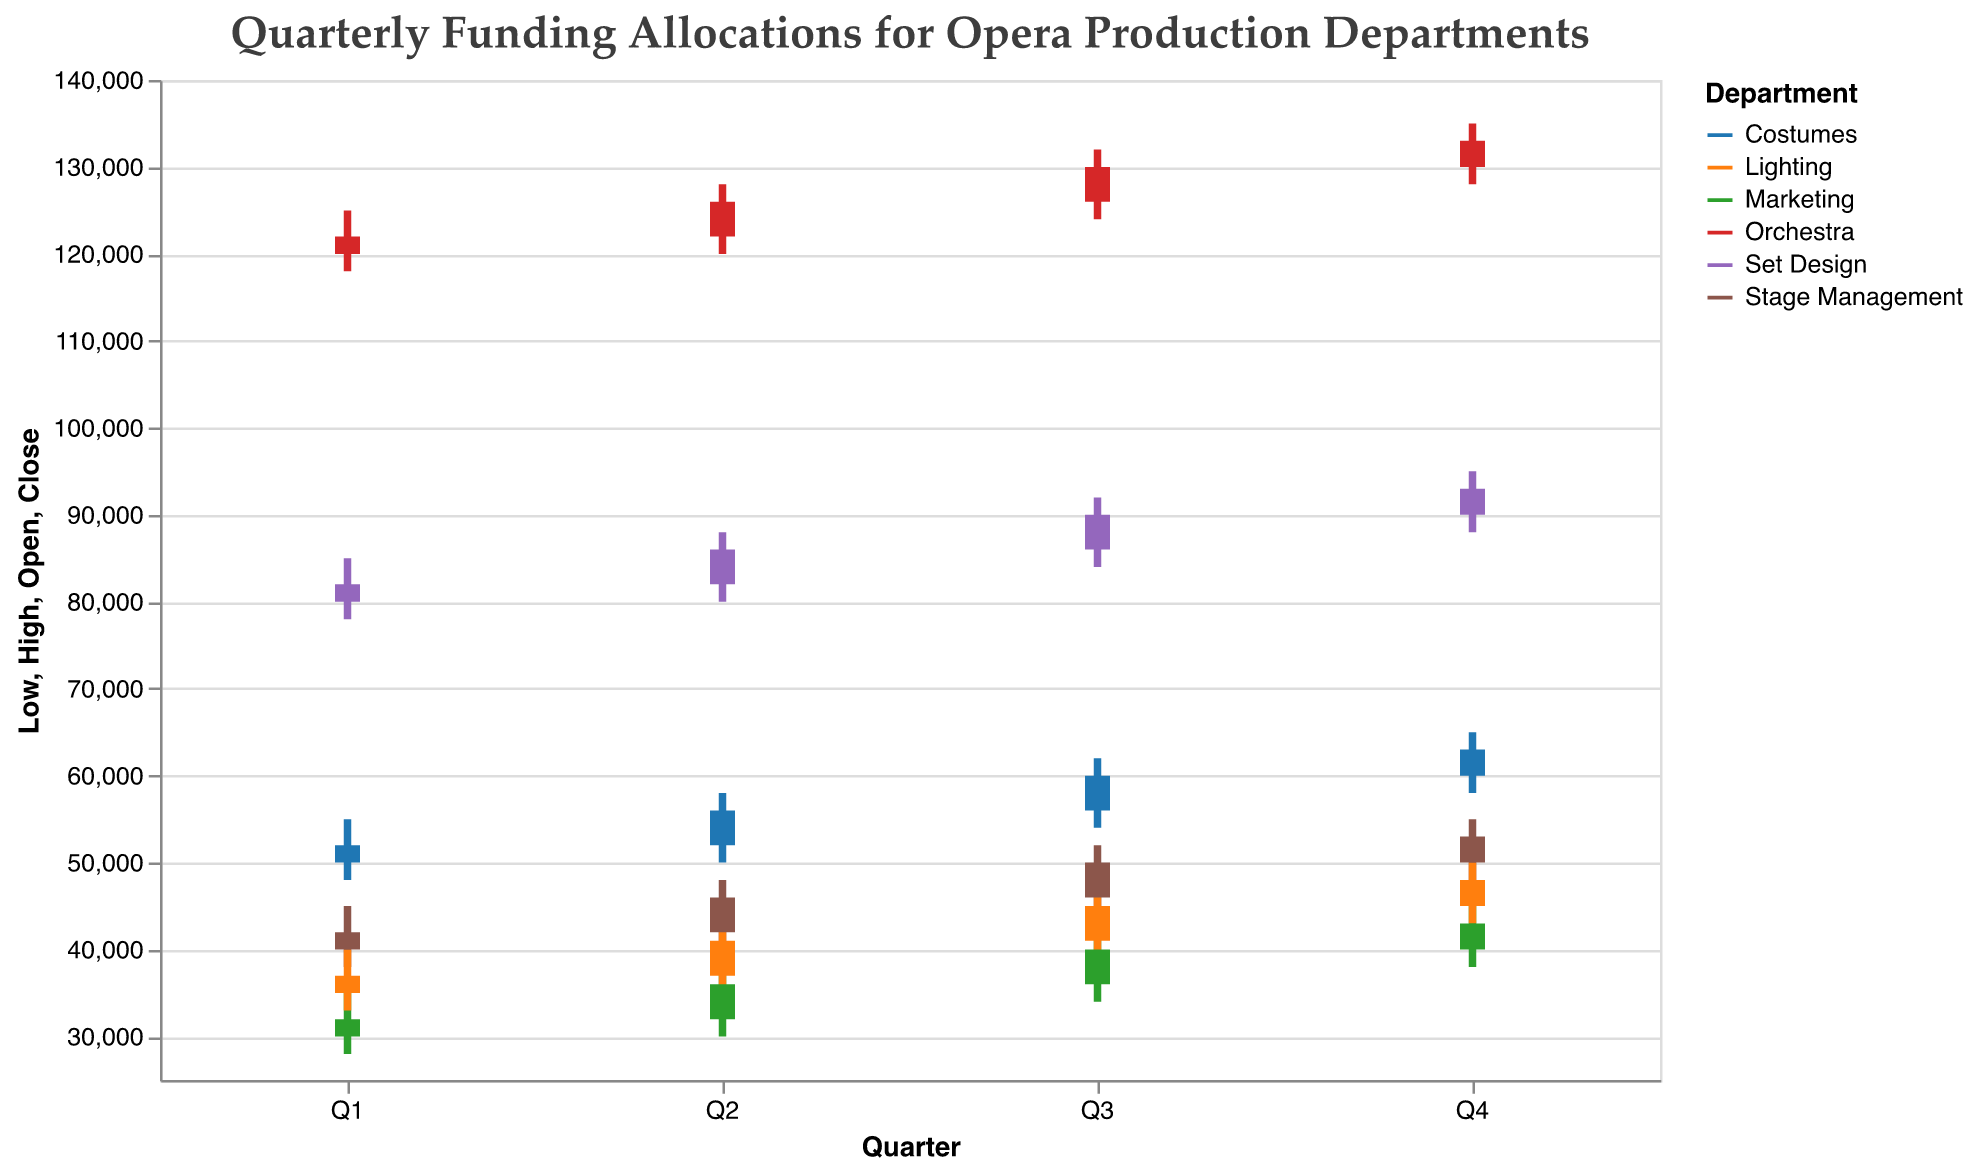What is the title of the chart? The title is displayed at the top of the chart, indicating its content, which is about funding allocations per quarter for various opera production departments.
Answer: Quarterly Funding Allocations for Opera Production Departments Which department received the highest funding in Q1? By examining the high values for Q1 of each department, the Orchestra department has the highest amount with $125,000.
Answer: Orchestra Compare the Q2 high values between Costumes and Lighting departments. Which department has a higher value and by how much? Costumes have a Q2 high value of $58,000 and Lighting has $43,000. The difference is $58,000 - $43,000 = $15,000.
Answer: Costumes, $15,000 Which department had the lowest funding in Q4 and what was the amount? By assessing the low values for Q4 of each department, Marketing had the lowest with $38,000.
Answer: Marketing, $38,000 Calculate the average of the Q3 closing values for Stage Management and Lighting departments. For Q3, Stage Management's closing value is $50,000 and Lighting's is $45,000. The average is (50,000 + 45,000) / 2 = $47,500.
Answer: $47,500 Did any department have the same opening and closing values in any quarter? If yes, identify the department(s) and the quarter(s). We need to check each department's opening and closing values for each quarter. Marketing had the same values in Q1 ($30,000 for both), and also in Q2, Q3, and Q4. Both Costumes and Lighting had identical opening and closing values in Q3 and Q4 respectively.
Answer: Marketing (Q1, Q2, Q3, Q4), Costumes (Q3), Lighting (Q4) Which department showed the most significant fluctuation in Q4 and what was the range? Fluctuation can be measured as the difference between the high and low values. The Orchestra department in Q4 had high value $135,000 and low value $128,000; the fluctuation is $135,000 - $128,000 = $7,000.
Answer: Orchestra, $7,000 